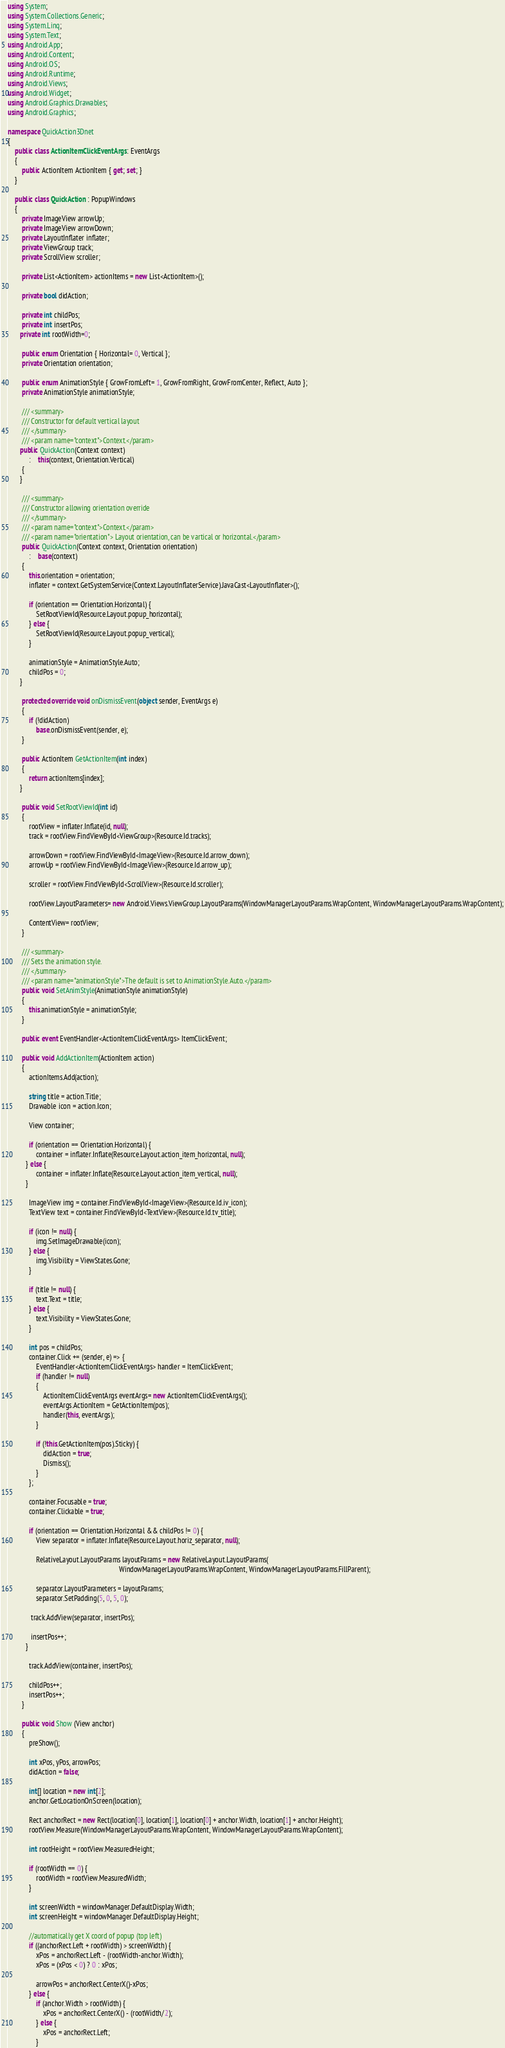Convert code to text. <code><loc_0><loc_0><loc_500><loc_500><_C#_>using System;
using System.Collections.Generic;
using System.Linq;
using System.Text;
using Android.App;
using Android.Content;
using Android.OS;
using Android.Runtime;
using Android.Views;
using Android.Widget;
using Android.Graphics.Drawables;
using Android.Graphics;

namespace QuickAction3Dnet
{
	public class ActionItemClickEventArgs : EventArgs
	{
		public ActionItem ActionItem { get; set; }
	}

	public class QuickAction : PopupWindows 
	{
		private ImageView arrowUp;
		private ImageView arrowDown;
		private LayoutInflater inflater;
		private ViewGroup track;
		private ScrollView scroller;
		
		private List<ActionItem> actionItems = new List<ActionItem>();
		
		private bool didAction;
		
		private int childPos;
		private int insertPos;
	   private int rootWidth=0;
	    
		public enum Orientation { Horizontal= 0, Vertical };
		private Orientation orientation;
	   
		public enum AnimationStyle { GrowFromLeft= 1, GrowFromRight, GrowFromCenter, Reflect, Auto }; 
		private AnimationStyle animationStyle;

		/// <summary>
		/// Constructor for default vertical layout
		/// </summary>
		/// <param name="context">Context.</param>
	   public QuickAction(Context context)
			:	this(context, Orientation.Vertical) 
		{
	   }

		/// <summary>
		/// Constructor allowing orientation override
		/// </summary>
		/// <param name="context">Context.</param>
		/// <param name="orientation"> Layout orientation, can be vartical or horizontal.</param>
		public QuickAction(Context context, Orientation orientation) 
			:	base(context)
		{
			this.orientation = orientation;	        
			inflater = context.GetSystemService(Context.LayoutInflaterService).JavaCast<LayoutInflater>();

			if (orientation == Orientation.Horizontal) {
				SetRootViewId(Resource.Layout.popup_horizontal);
			} else {
				SetRootViewId(Resource.Layout.popup_vertical);
			}

			animationStyle = AnimationStyle.Auto;
			childPos = 0;
	   }

		protected override void onDismissEvent(object sender, EventArgs e)
		{
			if (!didAction)
				base.onDismissEvent(sender, e);
		}

		public ActionItem GetActionItem(int index) 
		{
			return actionItems[index];
	   }
	    
		public void SetRootViewId(int id) 
		{
			rootView = inflater.Inflate(id, null);
			track = rootView.FindViewById<ViewGroup>(Resource.Id.tracks);

			arrowDown = rootView.FindViewById<ImageView>(Resource.Id.arrow_down);
			arrowUp = rootView.FindViewById<ImageView>(Resource.Id.arrow_up);

			scroller = rootView.FindViewById<ScrollView>(Resource.Id.scroller);

			rootView.LayoutParameters= new Android.Views.ViewGroup.LayoutParams(WindowManagerLayoutParams.WrapContent, WindowManagerLayoutParams.WrapContent);
			
			ContentView= rootView;
		}

		/// <summary>
		/// Sets the animation style.
		/// </summary>
		/// <param name="animationStyle">The default is set to AnimationStyle.Auto.</param>
		public void SetAnimStyle(AnimationStyle animationStyle) 
		{
			this.animationStyle = animationStyle;
		}
		
		public event EventHandler<ActionItemClickEventArgs> ItemClickEvent;
		
		public void AddActionItem(ActionItem action) 
		{
			actionItems.Add(action);
			
			string title = action.Title;
			Drawable icon = action.Icon;
			
			View container;
			
			if (orientation == Orientation.Horizontal) {
				container = inflater.Inflate(Resource.Layout.action_item_horizontal, null);
	      } else {
				container = inflater.Inflate(Resource.Layout.action_item_vertical, null);
	      }
			
			ImageView img = container.FindViewById<ImageView>(Resource.Id.iv_icon);
			TextView text = container.FindViewById<TextView>(Resource.Id.tv_title);
			
			if (icon != null) {
				img.SetImageDrawable(icon);
			} else {
				img.Visibility = ViewStates.Gone;
			}
			
			if (title != null) {
				text.Text = title;
			} else {
				text.Visibility = ViewStates.Gone;
			}
			
			int pos = childPos;
			container.Click += (sender, e) => {
				EventHandler<ActionItemClickEventArgs> handler = ItemClickEvent;
				if (handler != null)
				{
					ActionItemClickEventArgs eventArgs= new ActionItemClickEventArgs();
					eventArgs.ActionItem = GetActionItem(pos);
					handler(this, eventArgs);
				}

				if (!this.GetActionItem(pos).Sticky) {  
					didAction = true;
					Dismiss();
				}
			};

			container.Focusable = true;
			container.Clickable = true;
				 
			if (orientation == Orientation.Horizontal && childPos != 0) {
				View separator = inflater.Inflate(Resource.Layout.horiz_separator, null);
	         
				RelativeLayout.LayoutParams layoutParams = new RelativeLayout.LayoutParams(
					                                           WindowManagerLayoutParams.WrapContent, WindowManagerLayoutParams.FillParent);
	         
				separator.LayoutParameters = layoutParams;
				separator.SetPadding(5, 0, 5, 0);
	         
	         track.AddView(separator, insertPos);
	         
	         insertPos++;
	      }
			
			track.AddView(container, insertPos);
			
			childPos++;
			insertPos++;
		}
		
		public void Show (View anchor) 
		{
			preShow();
			
			int xPos, yPos, arrowPos;
			didAction = false;
			
			int[] location = new int[2];		
			anchor.GetLocationOnScreen(location);

			Rect anchorRect = new Rect(location[0], location[1], location[0] + anchor.Width, location[1] + anchor.Height);			
			rootView.Measure(WindowManagerLayoutParams.WrapContent, WindowManagerLayoutParams.WrapContent);
		
			int rootHeight = rootView.MeasuredHeight;
			
			if (rootWidth == 0) {
				rootWidth = rootView.MeasuredWidth;
			}
			
			int screenWidth = windowManager.DefaultDisplay.Width;
			int screenHeight = windowManager.DefaultDisplay.Height;
			
			//automatically get X coord of popup (top left)
			if ((anchorRect.Left + rootWidth) > screenWidth) {
				xPos = anchorRect.Left - (rootWidth-anchor.Width);
				xPos = (xPos < 0) ? 0 : xPos;
				
				arrowPos = anchorRect.CenterX()-xPos;				
			} else {
				if (anchor.Width > rootWidth) {
					xPos = anchorRect.CenterX() - (rootWidth/2);
				} else {
					xPos = anchorRect.Left;
				}				</code> 